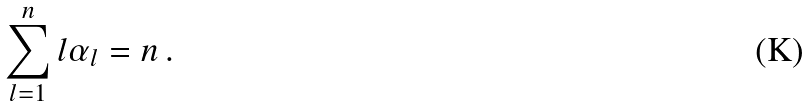<formula> <loc_0><loc_0><loc_500><loc_500>\sum _ { l = 1 } ^ { n } l \alpha _ { l } = n \, .</formula> 